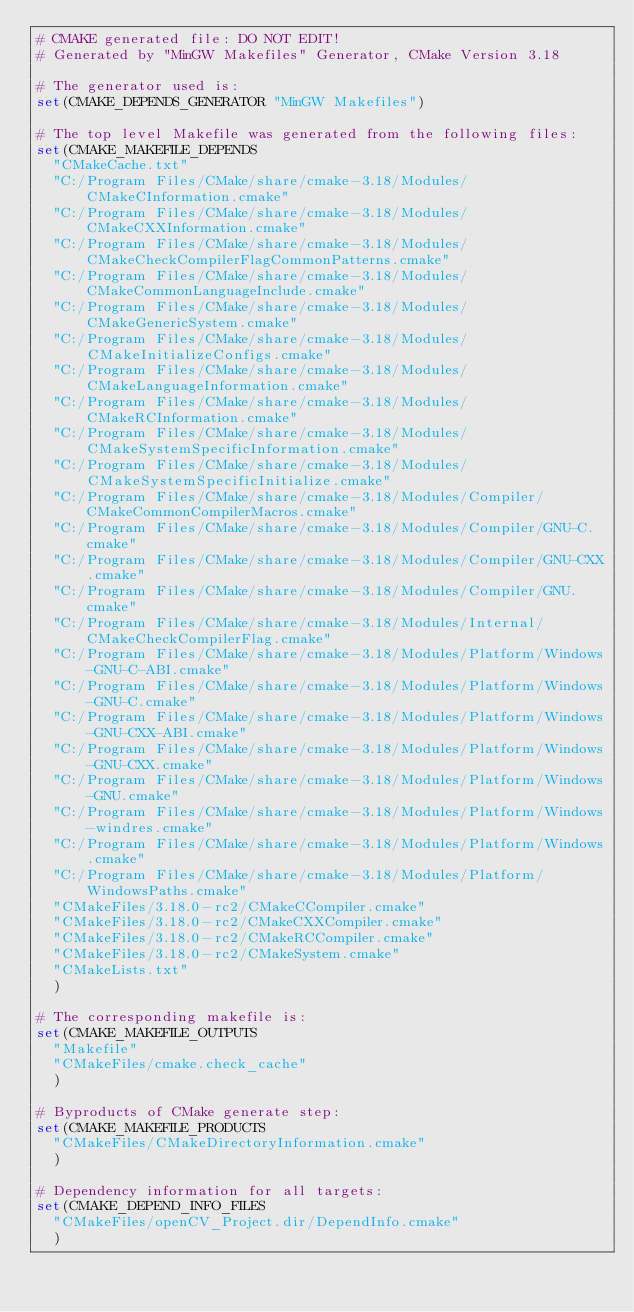<code> <loc_0><loc_0><loc_500><loc_500><_CMake_># CMAKE generated file: DO NOT EDIT!
# Generated by "MinGW Makefiles" Generator, CMake Version 3.18

# The generator used is:
set(CMAKE_DEPENDS_GENERATOR "MinGW Makefiles")

# The top level Makefile was generated from the following files:
set(CMAKE_MAKEFILE_DEPENDS
  "CMakeCache.txt"
  "C:/Program Files/CMake/share/cmake-3.18/Modules/CMakeCInformation.cmake"
  "C:/Program Files/CMake/share/cmake-3.18/Modules/CMakeCXXInformation.cmake"
  "C:/Program Files/CMake/share/cmake-3.18/Modules/CMakeCheckCompilerFlagCommonPatterns.cmake"
  "C:/Program Files/CMake/share/cmake-3.18/Modules/CMakeCommonLanguageInclude.cmake"
  "C:/Program Files/CMake/share/cmake-3.18/Modules/CMakeGenericSystem.cmake"
  "C:/Program Files/CMake/share/cmake-3.18/Modules/CMakeInitializeConfigs.cmake"
  "C:/Program Files/CMake/share/cmake-3.18/Modules/CMakeLanguageInformation.cmake"
  "C:/Program Files/CMake/share/cmake-3.18/Modules/CMakeRCInformation.cmake"
  "C:/Program Files/CMake/share/cmake-3.18/Modules/CMakeSystemSpecificInformation.cmake"
  "C:/Program Files/CMake/share/cmake-3.18/Modules/CMakeSystemSpecificInitialize.cmake"
  "C:/Program Files/CMake/share/cmake-3.18/Modules/Compiler/CMakeCommonCompilerMacros.cmake"
  "C:/Program Files/CMake/share/cmake-3.18/Modules/Compiler/GNU-C.cmake"
  "C:/Program Files/CMake/share/cmake-3.18/Modules/Compiler/GNU-CXX.cmake"
  "C:/Program Files/CMake/share/cmake-3.18/Modules/Compiler/GNU.cmake"
  "C:/Program Files/CMake/share/cmake-3.18/Modules/Internal/CMakeCheckCompilerFlag.cmake"
  "C:/Program Files/CMake/share/cmake-3.18/Modules/Platform/Windows-GNU-C-ABI.cmake"
  "C:/Program Files/CMake/share/cmake-3.18/Modules/Platform/Windows-GNU-C.cmake"
  "C:/Program Files/CMake/share/cmake-3.18/Modules/Platform/Windows-GNU-CXX-ABI.cmake"
  "C:/Program Files/CMake/share/cmake-3.18/Modules/Platform/Windows-GNU-CXX.cmake"
  "C:/Program Files/CMake/share/cmake-3.18/Modules/Platform/Windows-GNU.cmake"
  "C:/Program Files/CMake/share/cmake-3.18/Modules/Platform/Windows-windres.cmake"
  "C:/Program Files/CMake/share/cmake-3.18/Modules/Platform/Windows.cmake"
  "C:/Program Files/CMake/share/cmake-3.18/Modules/Platform/WindowsPaths.cmake"
  "CMakeFiles/3.18.0-rc2/CMakeCCompiler.cmake"
  "CMakeFiles/3.18.0-rc2/CMakeCXXCompiler.cmake"
  "CMakeFiles/3.18.0-rc2/CMakeRCCompiler.cmake"
  "CMakeFiles/3.18.0-rc2/CMakeSystem.cmake"
  "CMakeLists.txt"
  )

# The corresponding makefile is:
set(CMAKE_MAKEFILE_OUTPUTS
  "Makefile"
  "CMakeFiles/cmake.check_cache"
  )

# Byproducts of CMake generate step:
set(CMAKE_MAKEFILE_PRODUCTS
  "CMakeFiles/CMakeDirectoryInformation.cmake"
  )

# Dependency information for all targets:
set(CMAKE_DEPEND_INFO_FILES
  "CMakeFiles/openCV_Project.dir/DependInfo.cmake"
  )
</code> 